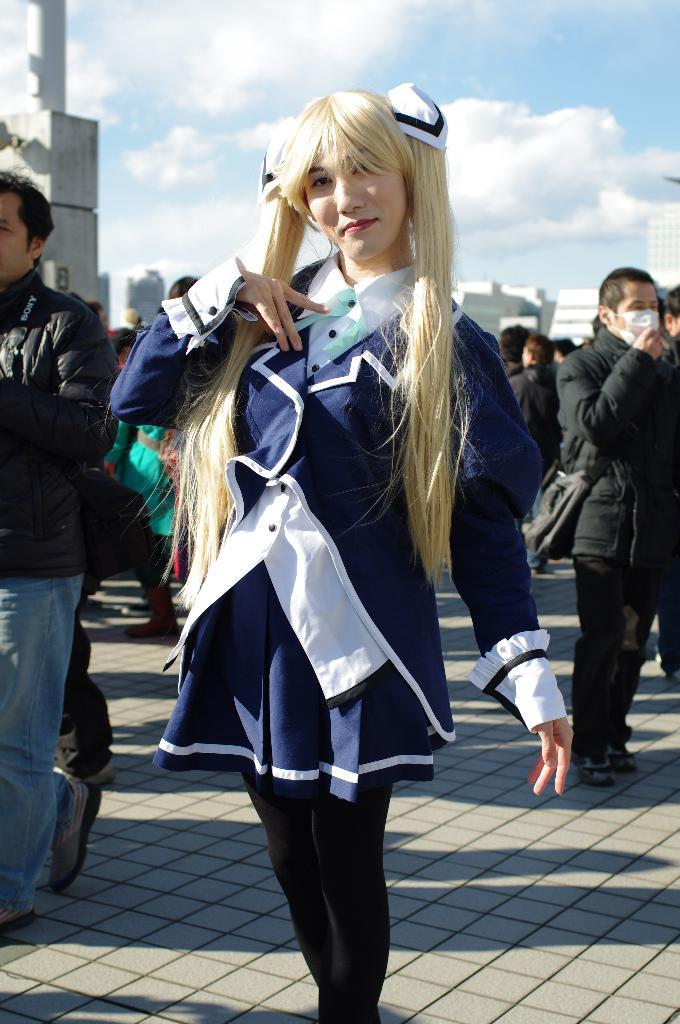Who is the main subject in the image? There is a woman standing in the middle of the image. What can be seen in the background of the image? There is a group of people and a building in the background of the image. What is visible at the top of the image? The sky is visible at the top of the image. How many bushes are present in the image? There are no bushes mentioned or visible in the image. What request does the woman make to her mom in the image? There is no indication of a request or conversation involving a mom in the image. 